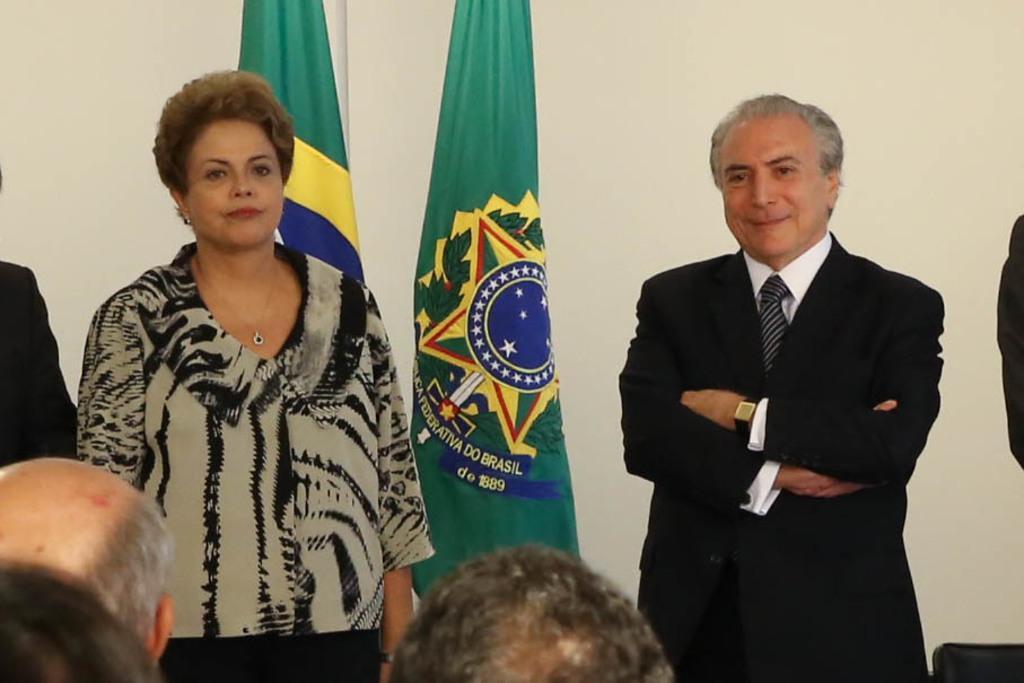Can you describe this image briefly? In the foreground of this picture we can see the group of people. In the center we can see the group of people standing and we can see the chairs. In the background we can see the flags containing the text, numbers and the depictions of leaves and some other objects and we can see a wall like object in the background. 